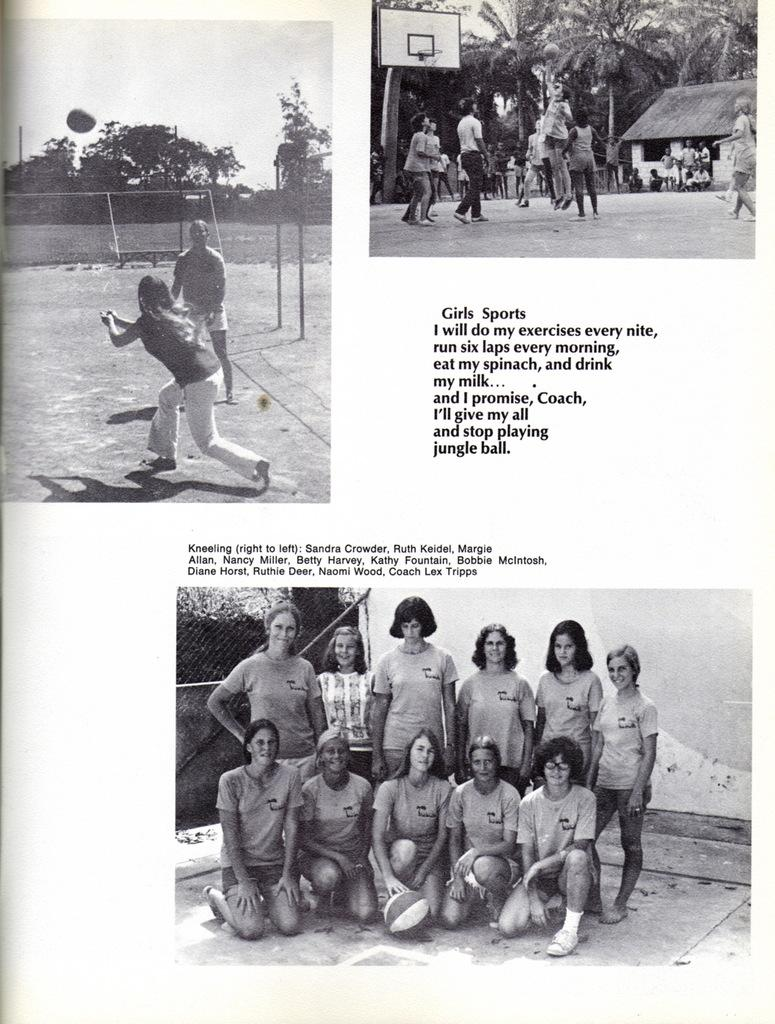What is the format of the image? The image is a collage of multiple images. What is present in between the images in the collage? There is text written in between the images. How does the crow contribute to the theme of love in the image? There is no crow present in the image, and therefore it cannot contribute to any theme. What type of health advice is given in the image? There is no health advice present in the image; it is a collage of multiple images with text in between. 